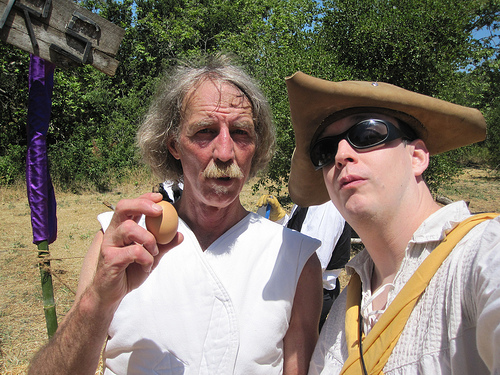<image>
Is the hat on the man? No. The hat is not positioned on the man. They may be near each other, but the hat is not supported by or resting on top of the man. 